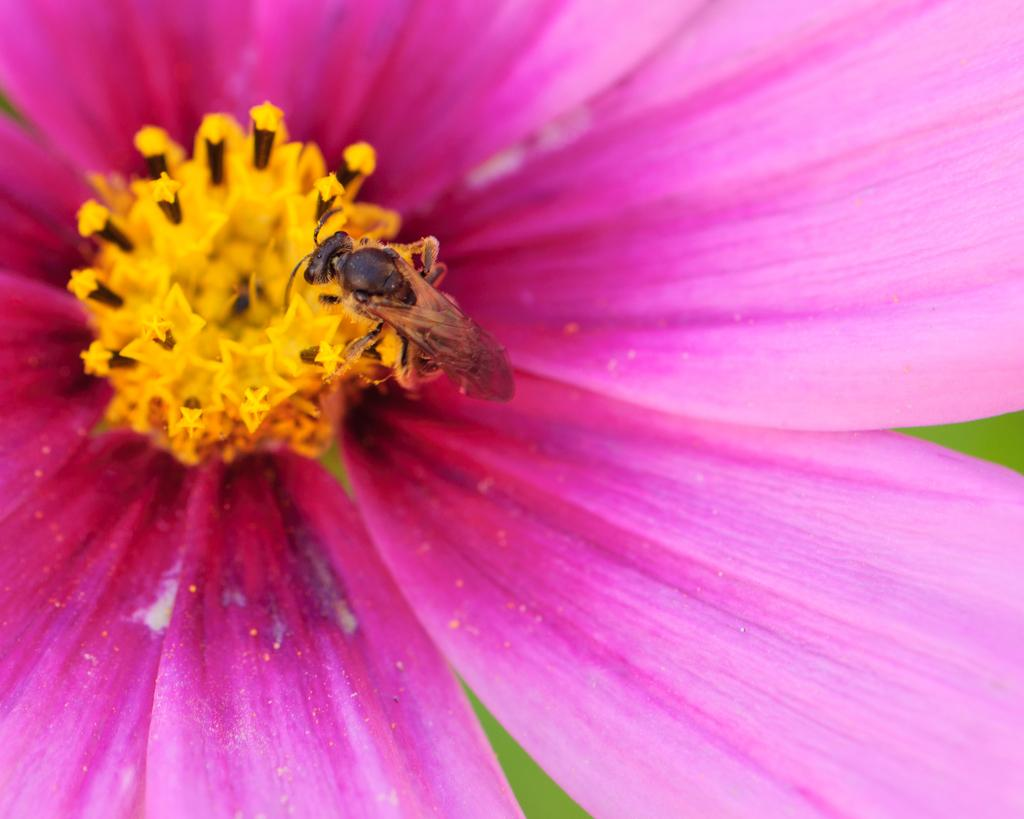What type of plant can be seen in the image? There is a flower in the image. What other living organism is present in the image? There is an insect in the image. How many sides does the square have in the image? There is no square present in the image. What type of spider can be seen in the image? There is no spider present in the image. 